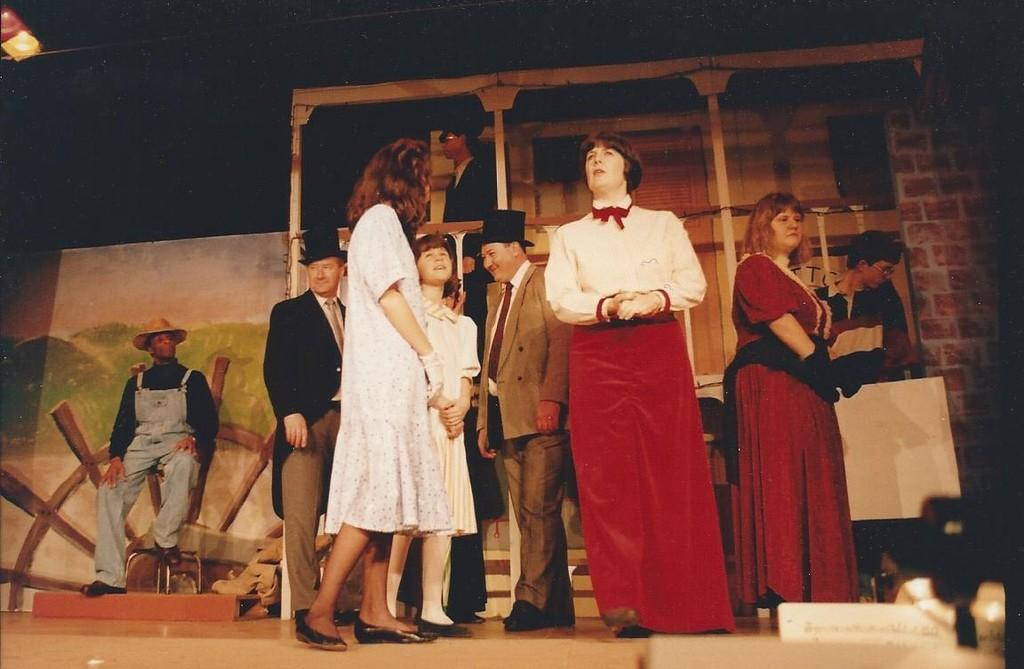How many people are present in the image? There are many people in the image. Where are the people standing in the image? The people are standing on a dais. What activity are the people engaged in? They appear to be performing a skit. What can be seen in the background of the image? There is a wall and a wooden board in the background of the image. What type of stitch is being used to sew the sand in the image? There is no stitch or sand present in the image; it features people standing on a dais and performing a skit. 